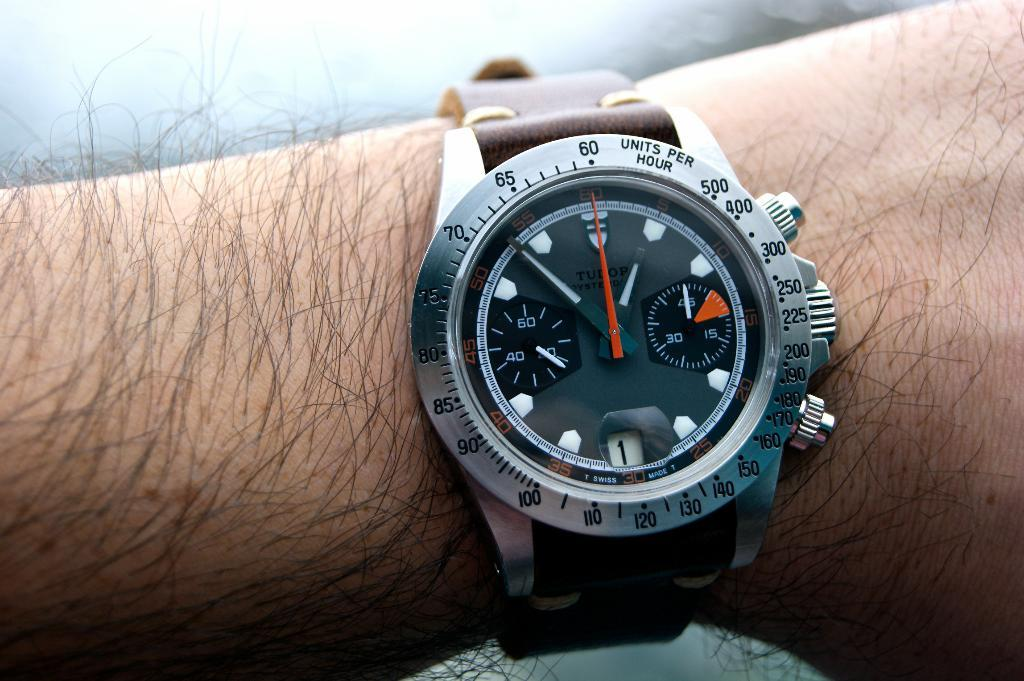<image>
Relay a brief, clear account of the picture shown. A man is checking the time on his Tudor brand watch. 